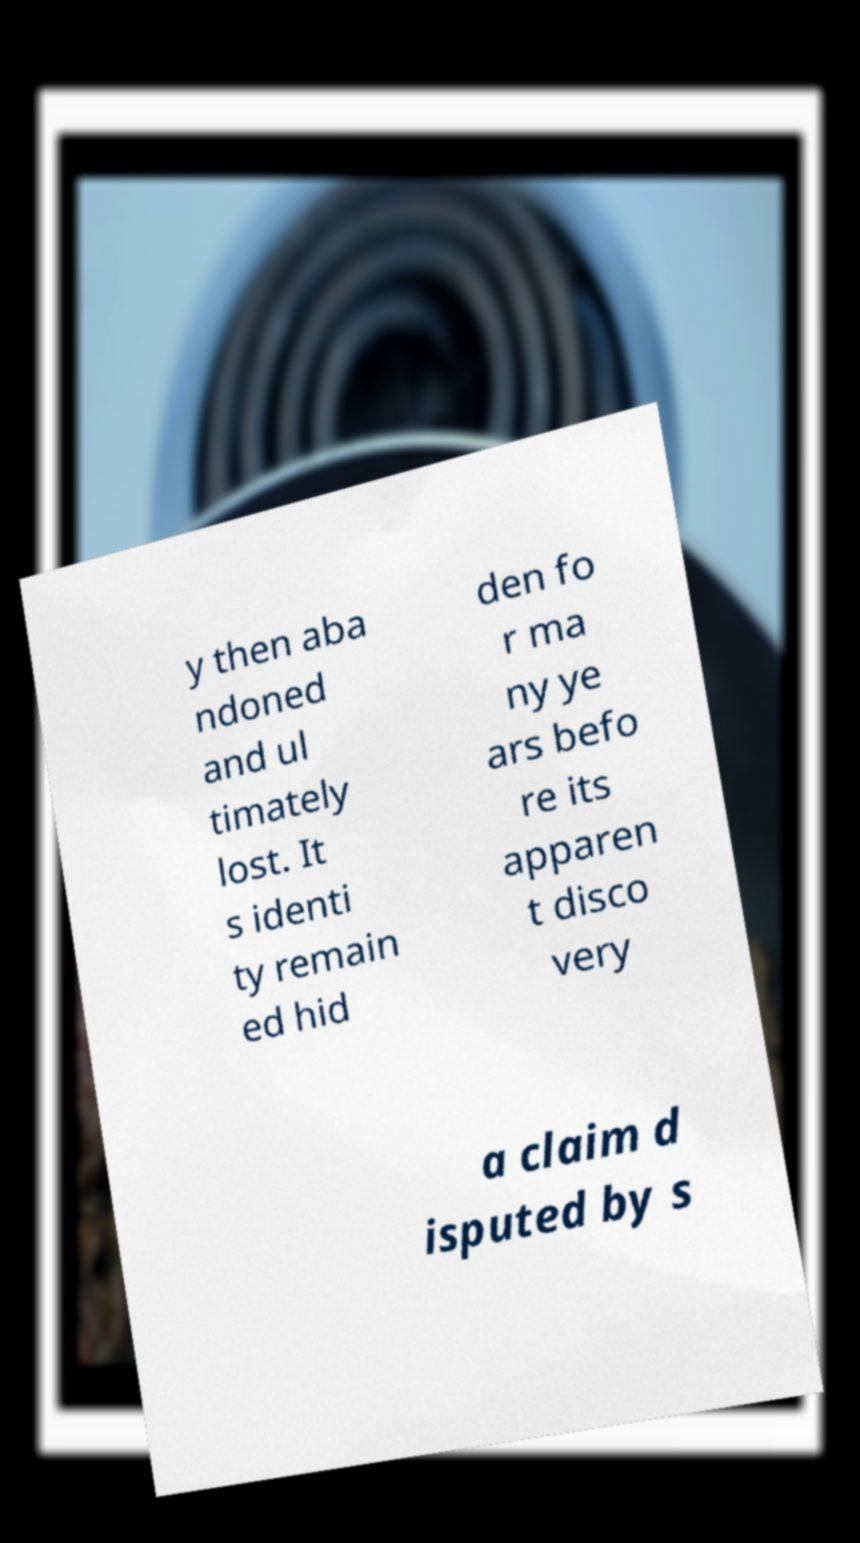Can you read and provide the text displayed in the image?This photo seems to have some interesting text. Can you extract and type it out for me? y then aba ndoned and ul timately lost. It s identi ty remain ed hid den fo r ma ny ye ars befo re its apparen t disco very a claim d isputed by s 